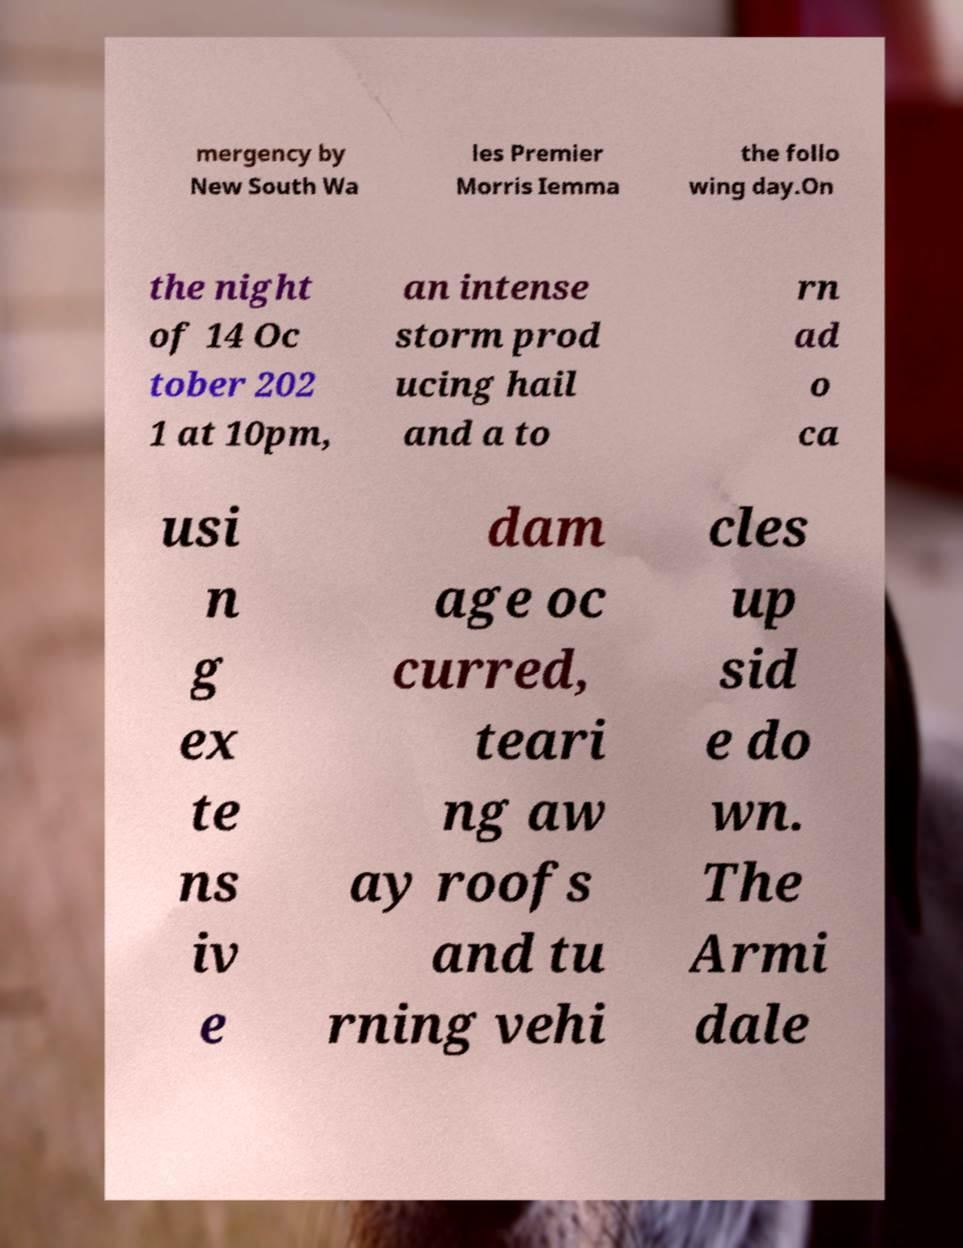What messages or text are displayed in this image? I need them in a readable, typed format. mergency by New South Wa les Premier Morris Iemma the follo wing day.On the night of 14 Oc tober 202 1 at 10pm, an intense storm prod ucing hail and a to rn ad o ca usi n g ex te ns iv e dam age oc curred, teari ng aw ay roofs and tu rning vehi cles up sid e do wn. The Armi dale 